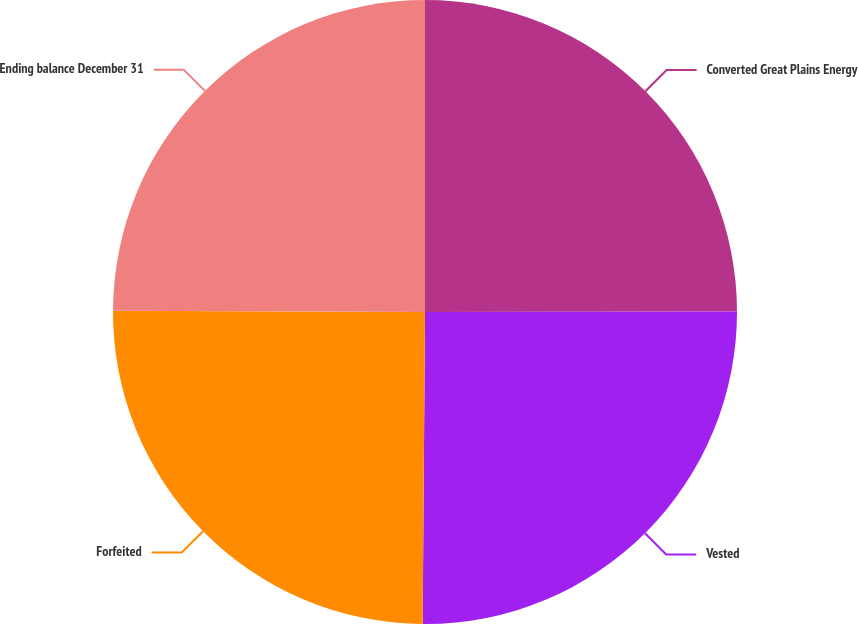Convert chart to OTSL. <chart><loc_0><loc_0><loc_500><loc_500><pie_chart><fcel>Converted Great Plains Energy<fcel>Vested<fcel>Forfeited<fcel>Ending balance December 31<nl><fcel>24.97%<fcel>25.15%<fcel>24.95%<fcel>24.93%<nl></chart> 